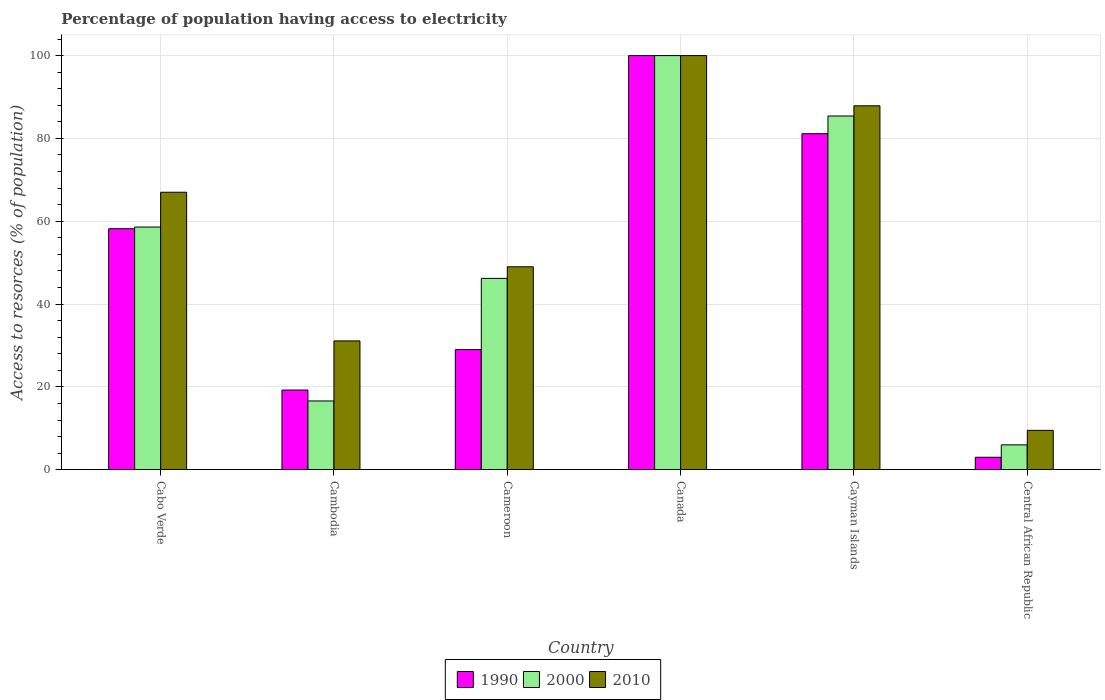How many different coloured bars are there?
Provide a succinct answer. 3. Are the number of bars on each tick of the X-axis equal?
Your answer should be compact. Yes. How many bars are there on the 6th tick from the right?
Give a very brief answer. 3. What is the label of the 4th group of bars from the left?
Provide a short and direct response. Canada. In how many cases, is the number of bars for a given country not equal to the number of legend labels?
Provide a short and direct response. 0. What is the percentage of population having access to electricity in 2010 in Cambodia?
Provide a short and direct response. 31.1. Across all countries, what is the maximum percentage of population having access to electricity in 2010?
Your response must be concise. 100. In which country was the percentage of population having access to electricity in 1990 minimum?
Your answer should be compact. Central African Republic. What is the total percentage of population having access to electricity in 1990 in the graph?
Keep it short and to the point. 290.56. What is the difference between the percentage of population having access to electricity in 1990 in Canada and that in Cayman Islands?
Give a very brief answer. 18.86. What is the difference between the percentage of population having access to electricity in 1990 in Cameroon and the percentage of population having access to electricity in 2000 in Cayman Islands?
Your answer should be very brief. -56.41. What is the average percentage of population having access to electricity in 2010 per country?
Offer a terse response. 57.41. In how many countries, is the percentage of population having access to electricity in 2000 greater than 12 %?
Keep it short and to the point. 5. What is the ratio of the percentage of population having access to electricity in 2010 in Canada to that in Central African Republic?
Offer a terse response. 10.53. Is the percentage of population having access to electricity in 2000 in Cambodia less than that in Central African Republic?
Give a very brief answer. No. Is the difference between the percentage of population having access to electricity in 2000 in Cameroon and Central African Republic greater than the difference between the percentage of population having access to electricity in 1990 in Cameroon and Central African Republic?
Provide a short and direct response. Yes. What is the difference between the highest and the second highest percentage of population having access to electricity in 1990?
Offer a very short reply. 22.95. What is the difference between the highest and the lowest percentage of population having access to electricity in 1990?
Provide a short and direct response. 97. In how many countries, is the percentage of population having access to electricity in 2000 greater than the average percentage of population having access to electricity in 2000 taken over all countries?
Make the answer very short. 3. Is the sum of the percentage of population having access to electricity in 1990 in Canada and Central African Republic greater than the maximum percentage of population having access to electricity in 2010 across all countries?
Give a very brief answer. Yes. What does the 1st bar from the left in Canada represents?
Your response must be concise. 1990. What does the 1st bar from the right in Cameroon represents?
Ensure brevity in your answer.  2010. Is it the case that in every country, the sum of the percentage of population having access to electricity in 1990 and percentage of population having access to electricity in 2000 is greater than the percentage of population having access to electricity in 2010?
Provide a succinct answer. No. How many bars are there?
Make the answer very short. 18. Are all the bars in the graph horizontal?
Your answer should be very brief. No. What is the difference between two consecutive major ticks on the Y-axis?
Offer a very short reply. 20. Does the graph contain grids?
Provide a short and direct response. Yes. Where does the legend appear in the graph?
Offer a terse response. Bottom center. How many legend labels are there?
Provide a short and direct response. 3. What is the title of the graph?
Offer a very short reply. Percentage of population having access to electricity. Does "2015" appear as one of the legend labels in the graph?
Give a very brief answer. No. What is the label or title of the X-axis?
Keep it short and to the point. Country. What is the label or title of the Y-axis?
Make the answer very short. Access to resorces (% of population). What is the Access to resorces (% of population) of 1990 in Cabo Verde?
Provide a succinct answer. 58.19. What is the Access to resorces (% of population) of 2000 in Cabo Verde?
Provide a succinct answer. 58.6. What is the Access to resorces (% of population) in 2010 in Cabo Verde?
Your response must be concise. 67. What is the Access to resorces (% of population) of 1990 in Cambodia?
Offer a very short reply. 19.24. What is the Access to resorces (% of population) of 2010 in Cambodia?
Give a very brief answer. 31.1. What is the Access to resorces (% of population) of 1990 in Cameroon?
Provide a succinct answer. 29. What is the Access to resorces (% of population) of 2000 in Cameroon?
Make the answer very short. 46.2. What is the Access to resorces (% of population) of 2010 in Cameroon?
Provide a short and direct response. 49. What is the Access to resorces (% of population) of 1990 in Cayman Islands?
Offer a very short reply. 81.14. What is the Access to resorces (% of population) of 2000 in Cayman Islands?
Give a very brief answer. 85.41. What is the Access to resorces (% of population) in 2010 in Cayman Islands?
Your answer should be very brief. 87.87. What is the Access to resorces (% of population) of 1990 in Central African Republic?
Offer a very short reply. 3. Across all countries, what is the maximum Access to resorces (% of population) of 1990?
Your answer should be compact. 100. Across all countries, what is the maximum Access to resorces (% of population) in 2000?
Provide a succinct answer. 100. Across all countries, what is the minimum Access to resorces (% of population) in 2000?
Your answer should be compact. 6. Across all countries, what is the minimum Access to resorces (% of population) of 2010?
Keep it short and to the point. 9.5. What is the total Access to resorces (% of population) of 1990 in the graph?
Your answer should be very brief. 290.56. What is the total Access to resorces (% of population) in 2000 in the graph?
Give a very brief answer. 312.81. What is the total Access to resorces (% of population) in 2010 in the graph?
Offer a terse response. 344.47. What is the difference between the Access to resorces (% of population) in 1990 in Cabo Verde and that in Cambodia?
Offer a very short reply. 38.95. What is the difference between the Access to resorces (% of population) in 2000 in Cabo Verde and that in Cambodia?
Make the answer very short. 42. What is the difference between the Access to resorces (% of population) of 2010 in Cabo Verde and that in Cambodia?
Your response must be concise. 35.9. What is the difference between the Access to resorces (% of population) in 1990 in Cabo Verde and that in Cameroon?
Offer a terse response. 29.19. What is the difference between the Access to resorces (% of population) in 2000 in Cabo Verde and that in Cameroon?
Your answer should be compact. 12.4. What is the difference between the Access to resorces (% of population) of 1990 in Cabo Verde and that in Canada?
Your response must be concise. -41.81. What is the difference between the Access to resorces (% of population) of 2000 in Cabo Verde and that in Canada?
Keep it short and to the point. -41.4. What is the difference between the Access to resorces (% of population) of 2010 in Cabo Verde and that in Canada?
Ensure brevity in your answer.  -33. What is the difference between the Access to resorces (% of population) of 1990 in Cabo Verde and that in Cayman Islands?
Offer a terse response. -22.95. What is the difference between the Access to resorces (% of population) in 2000 in Cabo Verde and that in Cayman Islands?
Keep it short and to the point. -26.81. What is the difference between the Access to resorces (% of population) in 2010 in Cabo Verde and that in Cayman Islands?
Your answer should be very brief. -20.87. What is the difference between the Access to resorces (% of population) of 1990 in Cabo Verde and that in Central African Republic?
Keep it short and to the point. 55.19. What is the difference between the Access to resorces (% of population) of 2000 in Cabo Verde and that in Central African Republic?
Ensure brevity in your answer.  52.6. What is the difference between the Access to resorces (% of population) of 2010 in Cabo Verde and that in Central African Republic?
Ensure brevity in your answer.  57.5. What is the difference between the Access to resorces (% of population) of 1990 in Cambodia and that in Cameroon?
Your answer should be compact. -9.76. What is the difference between the Access to resorces (% of population) in 2000 in Cambodia and that in Cameroon?
Make the answer very short. -29.6. What is the difference between the Access to resorces (% of population) of 2010 in Cambodia and that in Cameroon?
Ensure brevity in your answer.  -17.9. What is the difference between the Access to resorces (% of population) in 1990 in Cambodia and that in Canada?
Keep it short and to the point. -80.76. What is the difference between the Access to resorces (% of population) of 2000 in Cambodia and that in Canada?
Make the answer very short. -83.4. What is the difference between the Access to resorces (% of population) of 2010 in Cambodia and that in Canada?
Your response must be concise. -68.9. What is the difference between the Access to resorces (% of population) in 1990 in Cambodia and that in Cayman Islands?
Provide a succinct answer. -61.9. What is the difference between the Access to resorces (% of population) in 2000 in Cambodia and that in Cayman Islands?
Your answer should be very brief. -68.81. What is the difference between the Access to resorces (% of population) of 2010 in Cambodia and that in Cayman Islands?
Your answer should be compact. -56.77. What is the difference between the Access to resorces (% of population) in 1990 in Cambodia and that in Central African Republic?
Ensure brevity in your answer.  16.24. What is the difference between the Access to resorces (% of population) in 2010 in Cambodia and that in Central African Republic?
Your response must be concise. 21.6. What is the difference between the Access to resorces (% of population) in 1990 in Cameroon and that in Canada?
Provide a succinct answer. -71. What is the difference between the Access to resorces (% of population) in 2000 in Cameroon and that in Canada?
Provide a succinct answer. -53.8. What is the difference between the Access to resorces (% of population) in 2010 in Cameroon and that in Canada?
Offer a very short reply. -51. What is the difference between the Access to resorces (% of population) in 1990 in Cameroon and that in Cayman Islands?
Your response must be concise. -52.14. What is the difference between the Access to resorces (% of population) in 2000 in Cameroon and that in Cayman Islands?
Make the answer very short. -39.21. What is the difference between the Access to resorces (% of population) of 2010 in Cameroon and that in Cayman Islands?
Provide a succinct answer. -38.87. What is the difference between the Access to resorces (% of population) in 2000 in Cameroon and that in Central African Republic?
Provide a short and direct response. 40.2. What is the difference between the Access to resorces (% of population) in 2010 in Cameroon and that in Central African Republic?
Ensure brevity in your answer.  39.5. What is the difference between the Access to resorces (% of population) of 1990 in Canada and that in Cayman Islands?
Give a very brief answer. 18.86. What is the difference between the Access to resorces (% of population) of 2000 in Canada and that in Cayman Islands?
Give a very brief answer. 14.59. What is the difference between the Access to resorces (% of population) in 2010 in Canada and that in Cayman Islands?
Keep it short and to the point. 12.13. What is the difference between the Access to resorces (% of population) of 1990 in Canada and that in Central African Republic?
Your answer should be very brief. 97. What is the difference between the Access to resorces (% of population) in 2000 in Canada and that in Central African Republic?
Your response must be concise. 94. What is the difference between the Access to resorces (% of population) of 2010 in Canada and that in Central African Republic?
Provide a short and direct response. 90.5. What is the difference between the Access to resorces (% of population) of 1990 in Cayman Islands and that in Central African Republic?
Provide a succinct answer. 78.14. What is the difference between the Access to resorces (% of population) of 2000 in Cayman Islands and that in Central African Republic?
Your answer should be compact. 79.41. What is the difference between the Access to resorces (% of population) in 2010 in Cayman Islands and that in Central African Republic?
Provide a short and direct response. 78.37. What is the difference between the Access to resorces (% of population) in 1990 in Cabo Verde and the Access to resorces (% of population) in 2000 in Cambodia?
Give a very brief answer. 41.59. What is the difference between the Access to resorces (% of population) of 1990 in Cabo Verde and the Access to resorces (% of population) of 2010 in Cambodia?
Ensure brevity in your answer.  27.09. What is the difference between the Access to resorces (% of population) in 2000 in Cabo Verde and the Access to resorces (% of population) in 2010 in Cambodia?
Your response must be concise. 27.5. What is the difference between the Access to resorces (% of population) in 1990 in Cabo Verde and the Access to resorces (% of population) in 2000 in Cameroon?
Your response must be concise. 11.99. What is the difference between the Access to resorces (% of population) in 1990 in Cabo Verde and the Access to resorces (% of population) in 2010 in Cameroon?
Provide a short and direct response. 9.19. What is the difference between the Access to resorces (% of population) of 2000 in Cabo Verde and the Access to resorces (% of population) of 2010 in Cameroon?
Provide a succinct answer. 9.6. What is the difference between the Access to resorces (% of population) of 1990 in Cabo Verde and the Access to resorces (% of population) of 2000 in Canada?
Offer a very short reply. -41.81. What is the difference between the Access to resorces (% of population) in 1990 in Cabo Verde and the Access to resorces (% of population) in 2010 in Canada?
Your response must be concise. -41.81. What is the difference between the Access to resorces (% of population) of 2000 in Cabo Verde and the Access to resorces (% of population) of 2010 in Canada?
Ensure brevity in your answer.  -41.4. What is the difference between the Access to resorces (% of population) in 1990 in Cabo Verde and the Access to resorces (% of population) in 2000 in Cayman Islands?
Offer a terse response. -27.22. What is the difference between the Access to resorces (% of population) of 1990 in Cabo Verde and the Access to resorces (% of population) of 2010 in Cayman Islands?
Offer a very short reply. -29.69. What is the difference between the Access to resorces (% of population) in 2000 in Cabo Verde and the Access to resorces (% of population) in 2010 in Cayman Islands?
Offer a terse response. -29.27. What is the difference between the Access to resorces (% of population) of 1990 in Cabo Verde and the Access to resorces (% of population) of 2000 in Central African Republic?
Ensure brevity in your answer.  52.19. What is the difference between the Access to resorces (% of population) in 1990 in Cabo Verde and the Access to resorces (% of population) in 2010 in Central African Republic?
Your answer should be very brief. 48.69. What is the difference between the Access to resorces (% of population) in 2000 in Cabo Verde and the Access to resorces (% of population) in 2010 in Central African Republic?
Give a very brief answer. 49.1. What is the difference between the Access to resorces (% of population) of 1990 in Cambodia and the Access to resorces (% of population) of 2000 in Cameroon?
Ensure brevity in your answer.  -26.96. What is the difference between the Access to resorces (% of population) in 1990 in Cambodia and the Access to resorces (% of population) in 2010 in Cameroon?
Make the answer very short. -29.76. What is the difference between the Access to resorces (% of population) in 2000 in Cambodia and the Access to resorces (% of population) in 2010 in Cameroon?
Your answer should be very brief. -32.4. What is the difference between the Access to resorces (% of population) of 1990 in Cambodia and the Access to resorces (% of population) of 2000 in Canada?
Your answer should be compact. -80.76. What is the difference between the Access to resorces (% of population) of 1990 in Cambodia and the Access to resorces (% of population) of 2010 in Canada?
Provide a short and direct response. -80.76. What is the difference between the Access to resorces (% of population) in 2000 in Cambodia and the Access to resorces (% of population) in 2010 in Canada?
Your response must be concise. -83.4. What is the difference between the Access to resorces (% of population) of 1990 in Cambodia and the Access to resorces (% of population) of 2000 in Cayman Islands?
Provide a short and direct response. -66.17. What is the difference between the Access to resorces (% of population) of 1990 in Cambodia and the Access to resorces (% of population) of 2010 in Cayman Islands?
Give a very brief answer. -68.64. What is the difference between the Access to resorces (% of population) in 2000 in Cambodia and the Access to resorces (% of population) in 2010 in Cayman Islands?
Offer a terse response. -71.27. What is the difference between the Access to resorces (% of population) in 1990 in Cambodia and the Access to resorces (% of population) in 2000 in Central African Republic?
Make the answer very short. 13.24. What is the difference between the Access to resorces (% of population) in 1990 in Cambodia and the Access to resorces (% of population) in 2010 in Central African Republic?
Give a very brief answer. 9.74. What is the difference between the Access to resorces (% of population) of 2000 in Cambodia and the Access to resorces (% of population) of 2010 in Central African Republic?
Offer a terse response. 7.1. What is the difference between the Access to resorces (% of population) in 1990 in Cameroon and the Access to resorces (% of population) in 2000 in Canada?
Your response must be concise. -71. What is the difference between the Access to resorces (% of population) in 1990 in Cameroon and the Access to resorces (% of population) in 2010 in Canada?
Provide a short and direct response. -71. What is the difference between the Access to resorces (% of population) in 2000 in Cameroon and the Access to resorces (% of population) in 2010 in Canada?
Offer a very short reply. -53.8. What is the difference between the Access to resorces (% of population) of 1990 in Cameroon and the Access to resorces (% of population) of 2000 in Cayman Islands?
Provide a succinct answer. -56.41. What is the difference between the Access to resorces (% of population) in 1990 in Cameroon and the Access to resorces (% of population) in 2010 in Cayman Islands?
Provide a succinct answer. -58.87. What is the difference between the Access to resorces (% of population) in 2000 in Cameroon and the Access to resorces (% of population) in 2010 in Cayman Islands?
Your answer should be compact. -41.67. What is the difference between the Access to resorces (% of population) of 2000 in Cameroon and the Access to resorces (% of population) of 2010 in Central African Republic?
Your response must be concise. 36.7. What is the difference between the Access to resorces (% of population) in 1990 in Canada and the Access to resorces (% of population) in 2000 in Cayman Islands?
Your answer should be compact. 14.59. What is the difference between the Access to resorces (% of population) in 1990 in Canada and the Access to resorces (% of population) in 2010 in Cayman Islands?
Your answer should be compact. 12.13. What is the difference between the Access to resorces (% of population) of 2000 in Canada and the Access to resorces (% of population) of 2010 in Cayman Islands?
Your response must be concise. 12.13. What is the difference between the Access to resorces (% of population) in 1990 in Canada and the Access to resorces (% of population) in 2000 in Central African Republic?
Offer a terse response. 94. What is the difference between the Access to resorces (% of population) in 1990 in Canada and the Access to resorces (% of population) in 2010 in Central African Republic?
Offer a terse response. 90.5. What is the difference between the Access to resorces (% of population) in 2000 in Canada and the Access to resorces (% of population) in 2010 in Central African Republic?
Keep it short and to the point. 90.5. What is the difference between the Access to resorces (% of population) in 1990 in Cayman Islands and the Access to resorces (% of population) in 2000 in Central African Republic?
Provide a succinct answer. 75.14. What is the difference between the Access to resorces (% of population) in 1990 in Cayman Islands and the Access to resorces (% of population) in 2010 in Central African Republic?
Your answer should be very brief. 71.64. What is the difference between the Access to resorces (% of population) in 2000 in Cayman Islands and the Access to resorces (% of population) in 2010 in Central African Republic?
Offer a very short reply. 75.91. What is the average Access to resorces (% of population) of 1990 per country?
Give a very brief answer. 48.43. What is the average Access to resorces (% of population) in 2000 per country?
Make the answer very short. 52.14. What is the average Access to resorces (% of population) of 2010 per country?
Offer a terse response. 57.41. What is the difference between the Access to resorces (% of population) in 1990 and Access to resorces (% of population) in 2000 in Cabo Verde?
Offer a terse response. -0.41. What is the difference between the Access to resorces (% of population) in 1990 and Access to resorces (% of population) in 2010 in Cabo Verde?
Your answer should be very brief. -8.81. What is the difference between the Access to resorces (% of population) in 2000 and Access to resorces (% of population) in 2010 in Cabo Verde?
Your response must be concise. -8.4. What is the difference between the Access to resorces (% of population) in 1990 and Access to resorces (% of population) in 2000 in Cambodia?
Provide a short and direct response. 2.64. What is the difference between the Access to resorces (% of population) of 1990 and Access to resorces (% of population) of 2010 in Cambodia?
Provide a short and direct response. -11.86. What is the difference between the Access to resorces (% of population) of 1990 and Access to resorces (% of population) of 2000 in Cameroon?
Provide a succinct answer. -17.2. What is the difference between the Access to resorces (% of population) in 2000 and Access to resorces (% of population) in 2010 in Cameroon?
Offer a very short reply. -2.8. What is the difference between the Access to resorces (% of population) in 1990 and Access to resorces (% of population) in 2000 in Canada?
Offer a terse response. 0. What is the difference between the Access to resorces (% of population) of 1990 and Access to resorces (% of population) of 2010 in Canada?
Ensure brevity in your answer.  0. What is the difference between the Access to resorces (% of population) in 2000 and Access to resorces (% of population) in 2010 in Canada?
Offer a terse response. 0. What is the difference between the Access to resorces (% of population) of 1990 and Access to resorces (% of population) of 2000 in Cayman Islands?
Make the answer very short. -4.28. What is the difference between the Access to resorces (% of population) in 1990 and Access to resorces (% of population) in 2010 in Cayman Islands?
Make the answer very short. -6.74. What is the difference between the Access to resorces (% of population) of 2000 and Access to resorces (% of population) of 2010 in Cayman Islands?
Give a very brief answer. -2.46. What is the difference between the Access to resorces (% of population) in 1990 and Access to resorces (% of population) in 2000 in Central African Republic?
Your answer should be compact. -3. What is the ratio of the Access to resorces (% of population) of 1990 in Cabo Verde to that in Cambodia?
Provide a succinct answer. 3.02. What is the ratio of the Access to resorces (% of population) in 2000 in Cabo Verde to that in Cambodia?
Your answer should be very brief. 3.53. What is the ratio of the Access to resorces (% of population) in 2010 in Cabo Verde to that in Cambodia?
Ensure brevity in your answer.  2.15. What is the ratio of the Access to resorces (% of population) of 1990 in Cabo Verde to that in Cameroon?
Your answer should be compact. 2.01. What is the ratio of the Access to resorces (% of population) in 2000 in Cabo Verde to that in Cameroon?
Make the answer very short. 1.27. What is the ratio of the Access to resorces (% of population) of 2010 in Cabo Verde to that in Cameroon?
Make the answer very short. 1.37. What is the ratio of the Access to resorces (% of population) of 1990 in Cabo Verde to that in Canada?
Make the answer very short. 0.58. What is the ratio of the Access to resorces (% of population) in 2000 in Cabo Verde to that in Canada?
Ensure brevity in your answer.  0.59. What is the ratio of the Access to resorces (% of population) in 2010 in Cabo Verde to that in Canada?
Keep it short and to the point. 0.67. What is the ratio of the Access to resorces (% of population) of 1990 in Cabo Verde to that in Cayman Islands?
Provide a succinct answer. 0.72. What is the ratio of the Access to resorces (% of population) of 2000 in Cabo Verde to that in Cayman Islands?
Keep it short and to the point. 0.69. What is the ratio of the Access to resorces (% of population) of 2010 in Cabo Verde to that in Cayman Islands?
Provide a succinct answer. 0.76. What is the ratio of the Access to resorces (% of population) in 1990 in Cabo Verde to that in Central African Republic?
Make the answer very short. 19.4. What is the ratio of the Access to resorces (% of population) in 2000 in Cabo Verde to that in Central African Republic?
Give a very brief answer. 9.77. What is the ratio of the Access to resorces (% of population) of 2010 in Cabo Verde to that in Central African Republic?
Give a very brief answer. 7.05. What is the ratio of the Access to resorces (% of population) in 1990 in Cambodia to that in Cameroon?
Your answer should be very brief. 0.66. What is the ratio of the Access to resorces (% of population) in 2000 in Cambodia to that in Cameroon?
Your answer should be very brief. 0.36. What is the ratio of the Access to resorces (% of population) in 2010 in Cambodia to that in Cameroon?
Give a very brief answer. 0.63. What is the ratio of the Access to resorces (% of population) in 1990 in Cambodia to that in Canada?
Make the answer very short. 0.19. What is the ratio of the Access to resorces (% of population) in 2000 in Cambodia to that in Canada?
Ensure brevity in your answer.  0.17. What is the ratio of the Access to resorces (% of population) in 2010 in Cambodia to that in Canada?
Ensure brevity in your answer.  0.31. What is the ratio of the Access to resorces (% of population) in 1990 in Cambodia to that in Cayman Islands?
Your answer should be compact. 0.24. What is the ratio of the Access to resorces (% of population) of 2000 in Cambodia to that in Cayman Islands?
Offer a terse response. 0.19. What is the ratio of the Access to resorces (% of population) in 2010 in Cambodia to that in Cayman Islands?
Provide a short and direct response. 0.35. What is the ratio of the Access to resorces (% of population) in 1990 in Cambodia to that in Central African Republic?
Provide a succinct answer. 6.41. What is the ratio of the Access to resorces (% of population) of 2000 in Cambodia to that in Central African Republic?
Your response must be concise. 2.77. What is the ratio of the Access to resorces (% of population) in 2010 in Cambodia to that in Central African Republic?
Provide a short and direct response. 3.27. What is the ratio of the Access to resorces (% of population) of 1990 in Cameroon to that in Canada?
Your answer should be very brief. 0.29. What is the ratio of the Access to resorces (% of population) of 2000 in Cameroon to that in Canada?
Ensure brevity in your answer.  0.46. What is the ratio of the Access to resorces (% of population) of 2010 in Cameroon to that in Canada?
Your answer should be very brief. 0.49. What is the ratio of the Access to resorces (% of population) of 1990 in Cameroon to that in Cayman Islands?
Ensure brevity in your answer.  0.36. What is the ratio of the Access to resorces (% of population) in 2000 in Cameroon to that in Cayman Islands?
Make the answer very short. 0.54. What is the ratio of the Access to resorces (% of population) in 2010 in Cameroon to that in Cayman Islands?
Keep it short and to the point. 0.56. What is the ratio of the Access to resorces (% of population) in 1990 in Cameroon to that in Central African Republic?
Offer a very short reply. 9.67. What is the ratio of the Access to resorces (% of population) of 2000 in Cameroon to that in Central African Republic?
Provide a succinct answer. 7.7. What is the ratio of the Access to resorces (% of population) in 2010 in Cameroon to that in Central African Republic?
Your answer should be compact. 5.16. What is the ratio of the Access to resorces (% of population) of 1990 in Canada to that in Cayman Islands?
Ensure brevity in your answer.  1.23. What is the ratio of the Access to resorces (% of population) in 2000 in Canada to that in Cayman Islands?
Your answer should be compact. 1.17. What is the ratio of the Access to resorces (% of population) in 2010 in Canada to that in Cayman Islands?
Keep it short and to the point. 1.14. What is the ratio of the Access to resorces (% of population) in 1990 in Canada to that in Central African Republic?
Keep it short and to the point. 33.33. What is the ratio of the Access to resorces (% of population) of 2000 in Canada to that in Central African Republic?
Provide a succinct answer. 16.67. What is the ratio of the Access to resorces (% of population) of 2010 in Canada to that in Central African Republic?
Provide a short and direct response. 10.53. What is the ratio of the Access to resorces (% of population) in 1990 in Cayman Islands to that in Central African Republic?
Your response must be concise. 27.05. What is the ratio of the Access to resorces (% of population) in 2000 in Cayman Islands to that in Central African Republic?
Ensure brevity in your answer.  14.24. What is the ratio of the Access to resorces (% of population) of 2010 in Cayman Islands to that in Central African Republic?
Offer a terse response. 9.25. What is the difference between the highest and the second highest Access to resorces (% of population) in 1990?
Provide a short and direct response. 18.86. What is the difference between the highest and the second highest Access to resorces (% of population) of 2000?
Offer a terse response. 14.59. What is the difference between the highest and the second highest Access to resorces (% of population) of 2010?
Your answer should be very brief. 12.13. What is the difference between the highest and the lowest Access to resorces (% of population) of 1990?
Offer a very short reply. 97. What is the difference between the highest and the lowest Access to resorces (% of population) in 2000?
Your response must be concise. 94. What is the difference between the highest and the lowest Access to resorces (% of population) in 2010?
Your response must be concise. 90.5. 